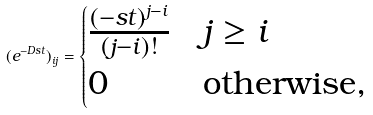<formula> <loc_0><loc_0><loc_500><loc_500>( e ^ { - D s t } ) _ { i j } = \begin{cases} \frac { ( - s t ) ^ { j - i } } { ( j - i ) ! } & j \geq i \\ 0 & \text {otherwise,} \end{cases}</formula> 